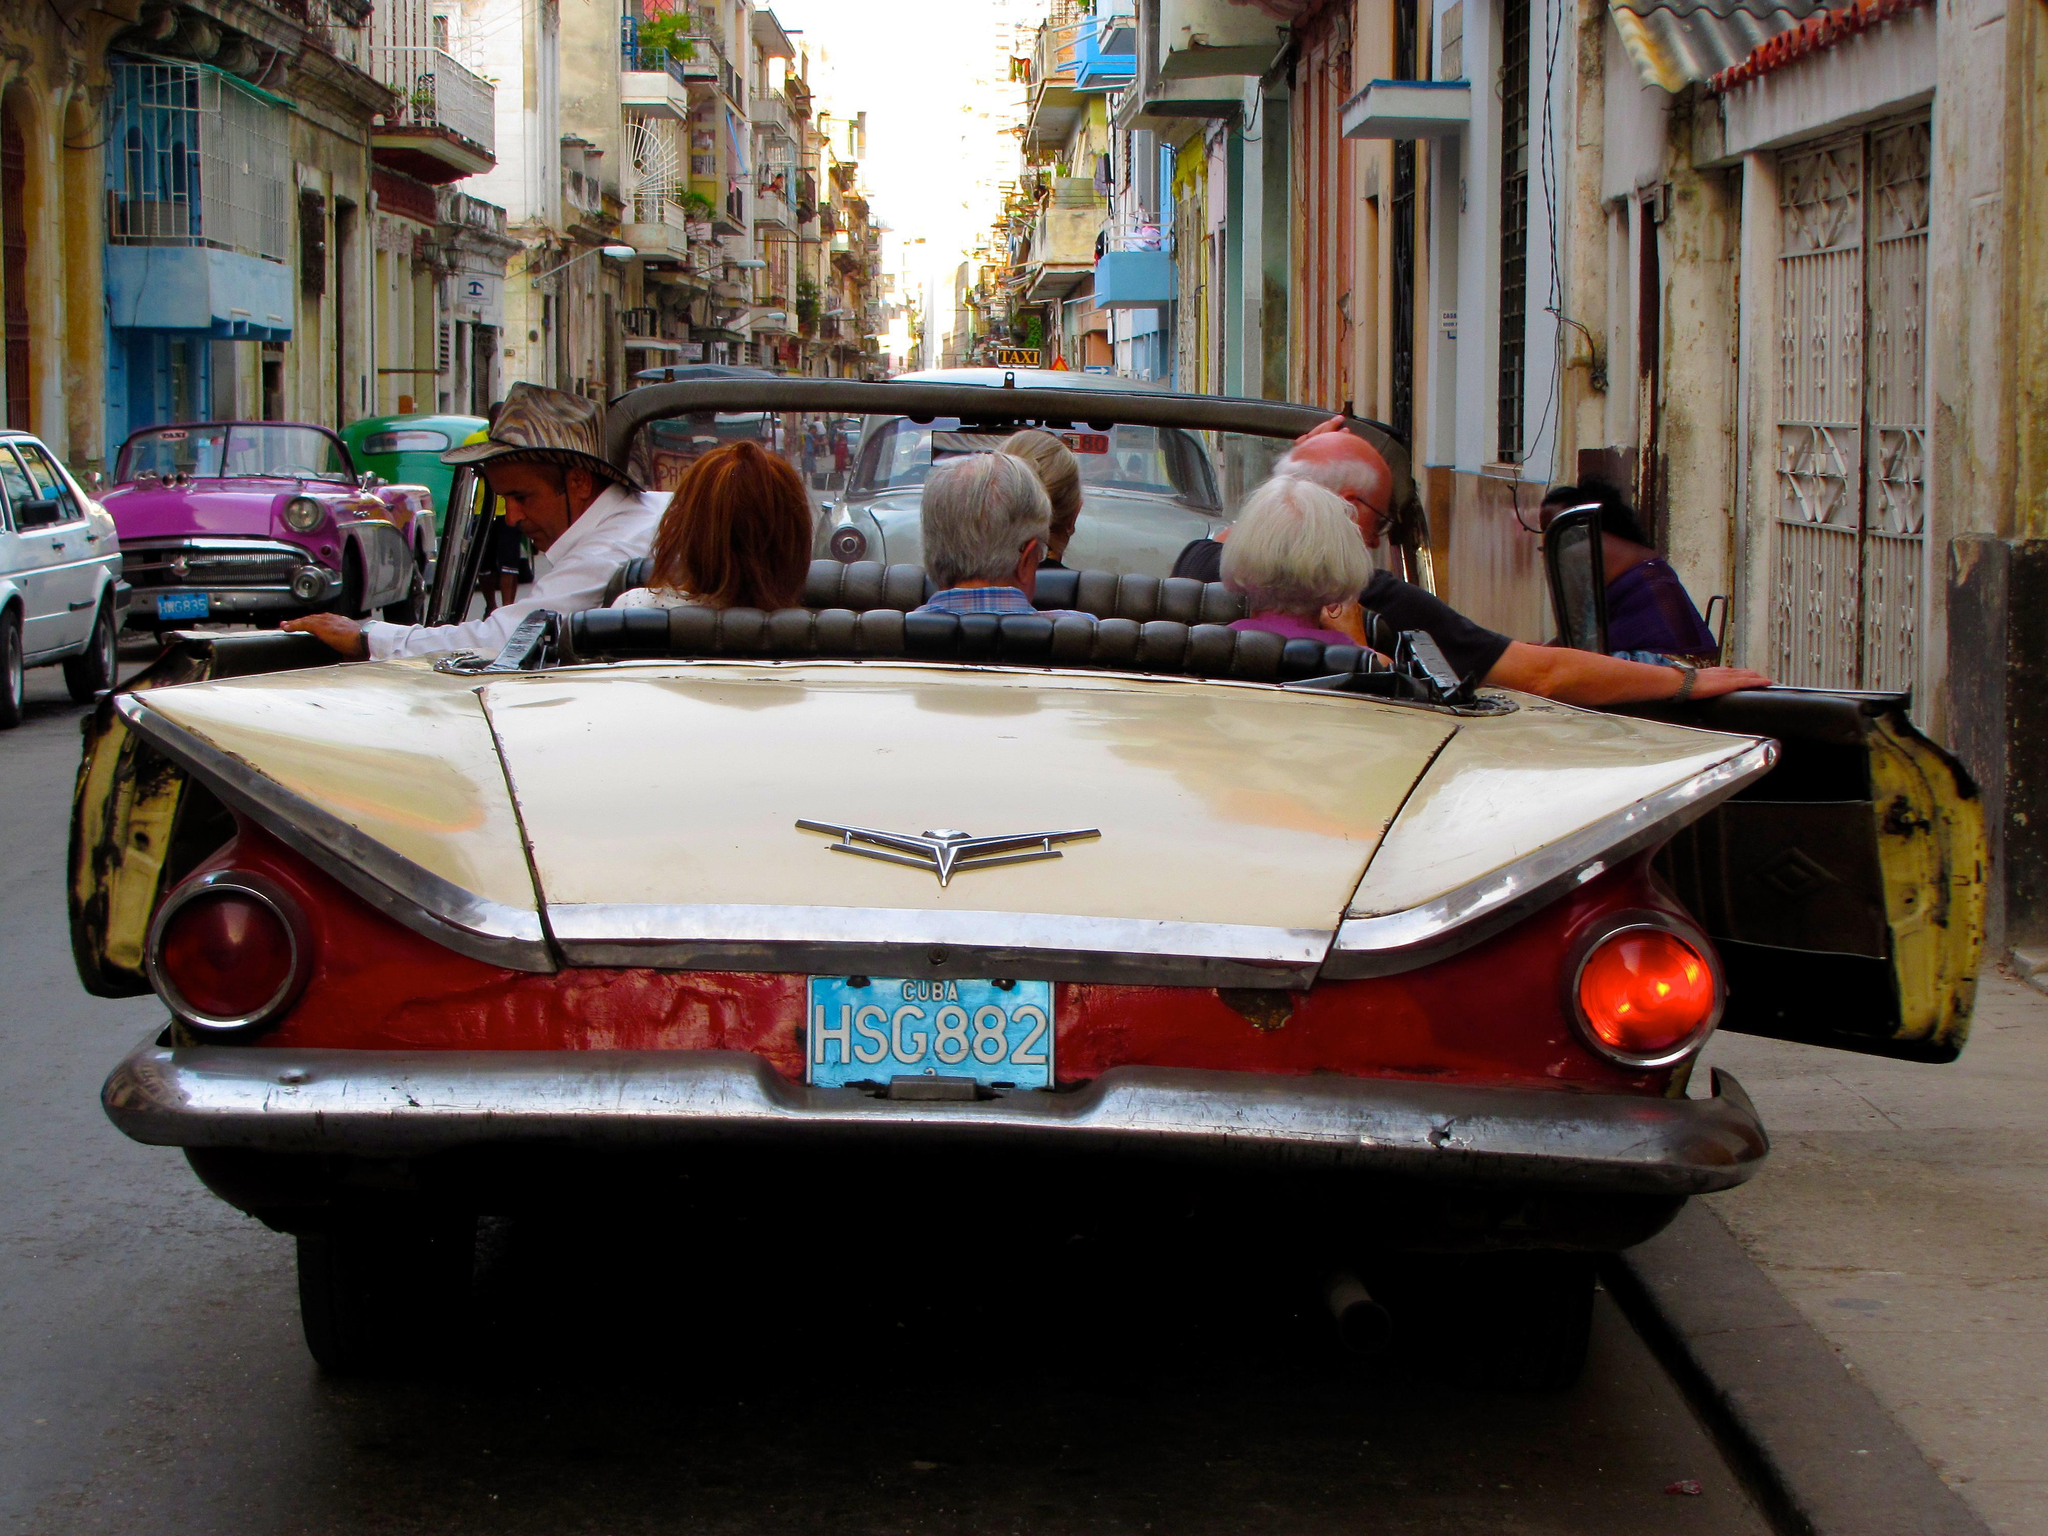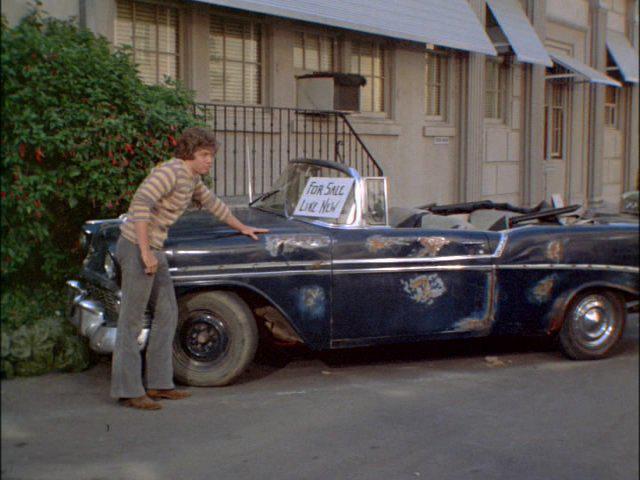The first image is the image on the left, the second image is the image on the right. Examine the images to the left and right. Is the description "Contains a car that is facing to the left side." accurate? Answer yes or no. Yes. The first image is the image on the left, the second image is the image on the right. For the images displayed, is the sentence "in the left image there is a sidewalk to the left of the car" factually correct? Answer yes or no. No. 